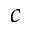Convert formula to latex. <formula><loc_0><loc_0><loc_500><loc_500>c</formula> 